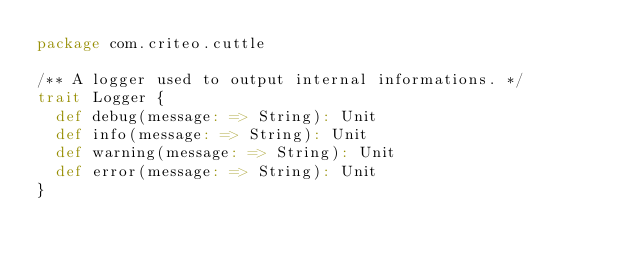<code> <loc_0><loc_0><loc_500><loc_500><_Scala_>package com.criteo.cuttle

/** A logger used to output internal informations. */
trait Logger {
  def debug(message: => String): Unit
  def info(message: => String): Unit
  def warning(message: => String): Unit
  def error(message: => String): Unit
}</code> 